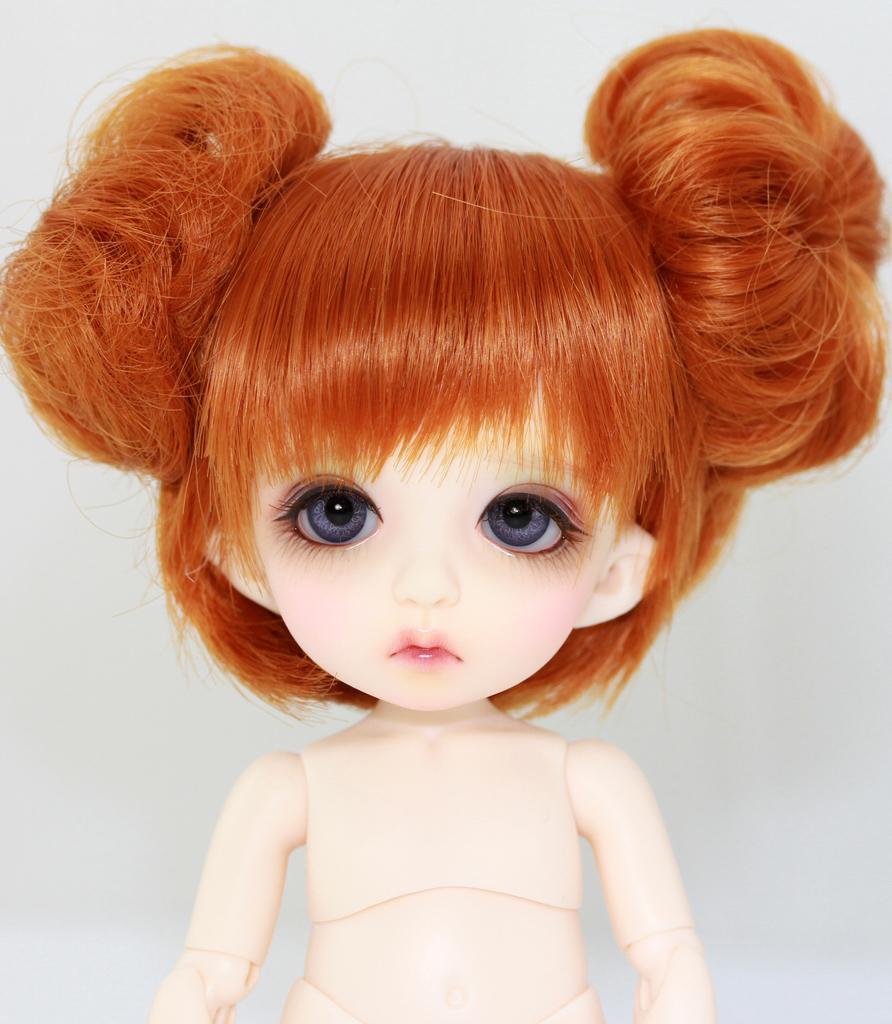Please provide a concise description of this image. In this picture we can see a toy. 